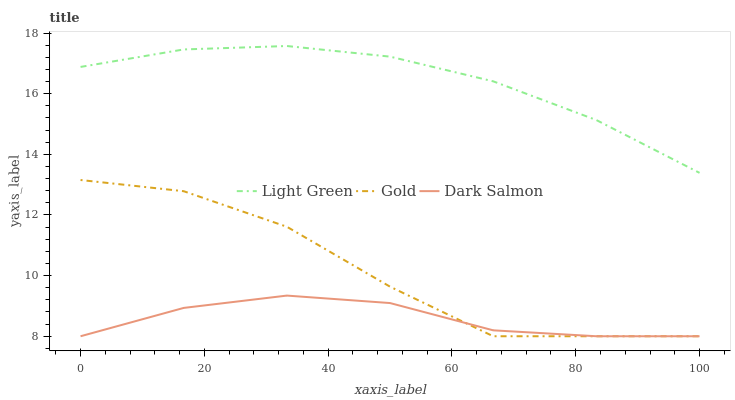Does Dark Salmon have the minimum area under the curve?
Answer yes or no. Yes. Does Light Green have the maximum area under the curve?
Answer yes or no. Yes. Does Light Green have the minimum area under the curve?
Answer yes or no. No. Does Dark Salmon have the maximum area under the curve?
Answer yes or no. No. Is Light Green the smoothest?
Answer yes or no. Yes. Is Gold the roughest?
Answer yes or no. Yes. Is Dark Salmon the smoothest?
Answer yes or no. No. Is Dark Salmon the roughest?
Answer yes or no. No. Does Gold have the lowest value?
Answer yes or no. Yes. Does Light Green have the lowest value?
Answer yes or no. No. Does Light Green have the highest value?
Answer yes or no. Yes. Does Dark Salmon have the highest value?
Answer yes or no. No. Is Gold less than Light Green?
Answer yes or no. Yes. Is Light Green greater than Gold?
Answer yes or no. Yes. Does Dark Salmon intersect Gold?
Answer yes or no. Yes. Is Dark Salmon less than Gold?
Answer yes or no. No. Is Dark Salmon greater than Gold?
Answer yes or no. No. Does Gold intersect Light Green?
Answer yes or no. No. 